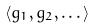Convert formula to latex. <formula><loc_0><loc_0><loc_500><loc_500>\langle g _ { 1 } , g _ { 2 } , \dots \rangle</formula> 